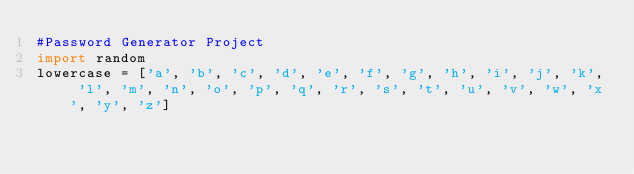<code> <loc_0><loc_0><loc_500><loc_500><_Python_>#Password Generator Project
import random
lowercase = ['a', 'b', 'c', 'd', 'e', 'f', 'g', 'h', 'i', 'j', 'k', 'l', 'm', 'n', 'o', 'p', 'q', 'r', 's', 't', 'u', 'v', 'w', 'x', 'y', 'z'] </code> 